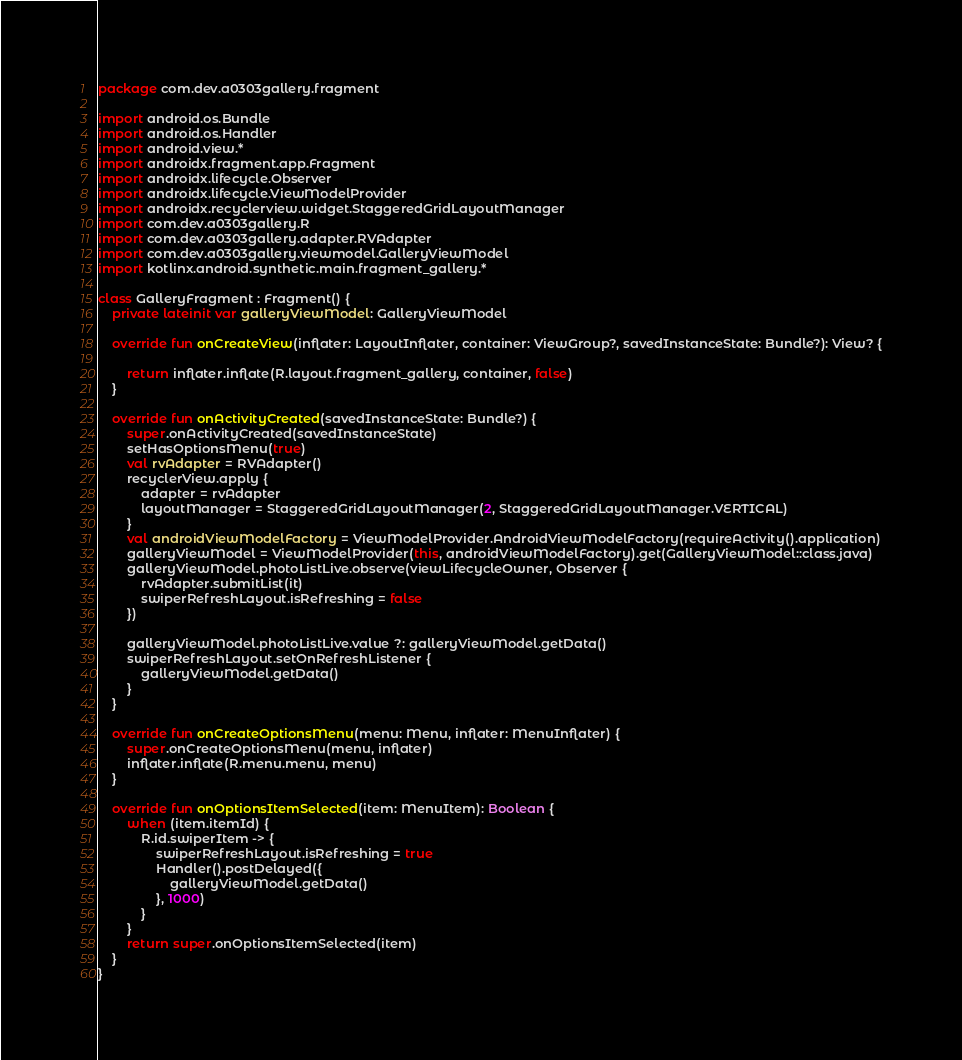Convert code to text. <code><loc_0><loc_0><loc_500><loc_500><_Kotlin_>package com.dev.a0303gallery.fragment

import android.os.Bundle
import android.os.Handler
import android.view.*
import androidx.fragment.app.Fragment
import androidx.lifecycle.Observer
import androidx.lifecycle.ViewModelProvider
import androidx.recyclerview.widget.StaggeredGridLayoutManager
import com.dev.a0303gallery.R
import com.dev.a0303gallery.adapter.RVAdapter
import com.dev.a0303gallery.viewmodel.GalleryViewModel
import kotlinx.android.synthetic.main.fragment_gallery.*

class GalleryFragment : Fragment() {
    private lateinit var galleryViewModel: GalleryViewModel

    override fun onCreateView(inflater: LayoutInflater, container: ViewGroup?, savedInstanceState: Bundle?): View? {

        return inflater.inflate(R.layout.fragment_gallery, container, false)
    }

    override fun onActivityCreated(savedInstanceState: Bundle?) {
        super.onActivityCreated(savedInstanceState)
        setHasOptionsMenu(true)
        val rvAdapter = RVAdapter()
        recyclerView.apply {
            adapter = rvAdapter
            layoutManager = StaggeredGridLayoutManager(2, StaggeredGridLayoutManager.VERTICAL)
        }
        val androidViewModelFactory = ViewModelProvider.AndroidViewModelFactory(requireActivity().application)
        galleryViewModel = ViewModelProvider(this, androidViewModelFactory).get(GalleryViewModel::class.java)
        galleryViewModel.photoListLive.observe(viewLifecycleOwner, Observer {
            rvAdapter.submitList(it)
            swiperRefreshLayout.isRefreshing = false
        })

        galleryViewModel.photoListLive.value ?: galleryViewModel.getData()
        swiperRefreshLayout.setOnRefreshListener {
            galleryViewModel.getData()
        }
    }

    override fun onCreateOptionsMenu(menu: Menu, inflater: MenuInflater) {
        super.onCreateOptionsMenu(menu, inflater)
        inflater.inflate(R.menu.menu, menu)
    }

    override fun onOptionsItemSelected(item: MenuItem): Boolean {
        when (item.itemId) {
            R.id.swiperItem -> {
                swiperRefreshLayout.isRefreshing = true
                Handler().postDelayed({
                    galleryViewModel.getData()
                }, 1000)
            }
        }
        return super.onOptionsItemSelected(item)
    }
}
</code> 